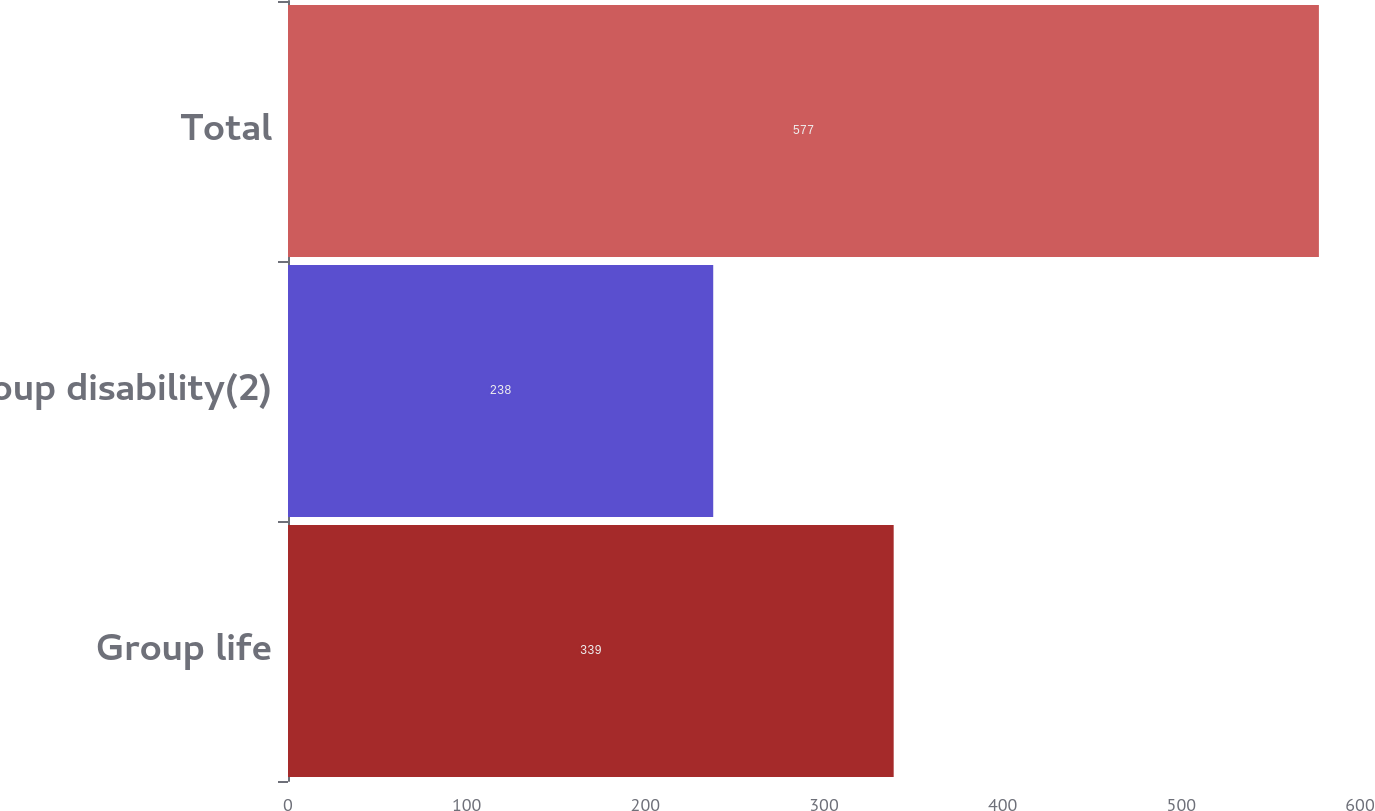<chart> <loc_0><loc_0><loc_500><loc_500><bar_chart><fcel>Group life<fcel>Group disability(2)<fcel>Total<nl><fcel>339<fcel>238<fcel>577<nl></chart> 